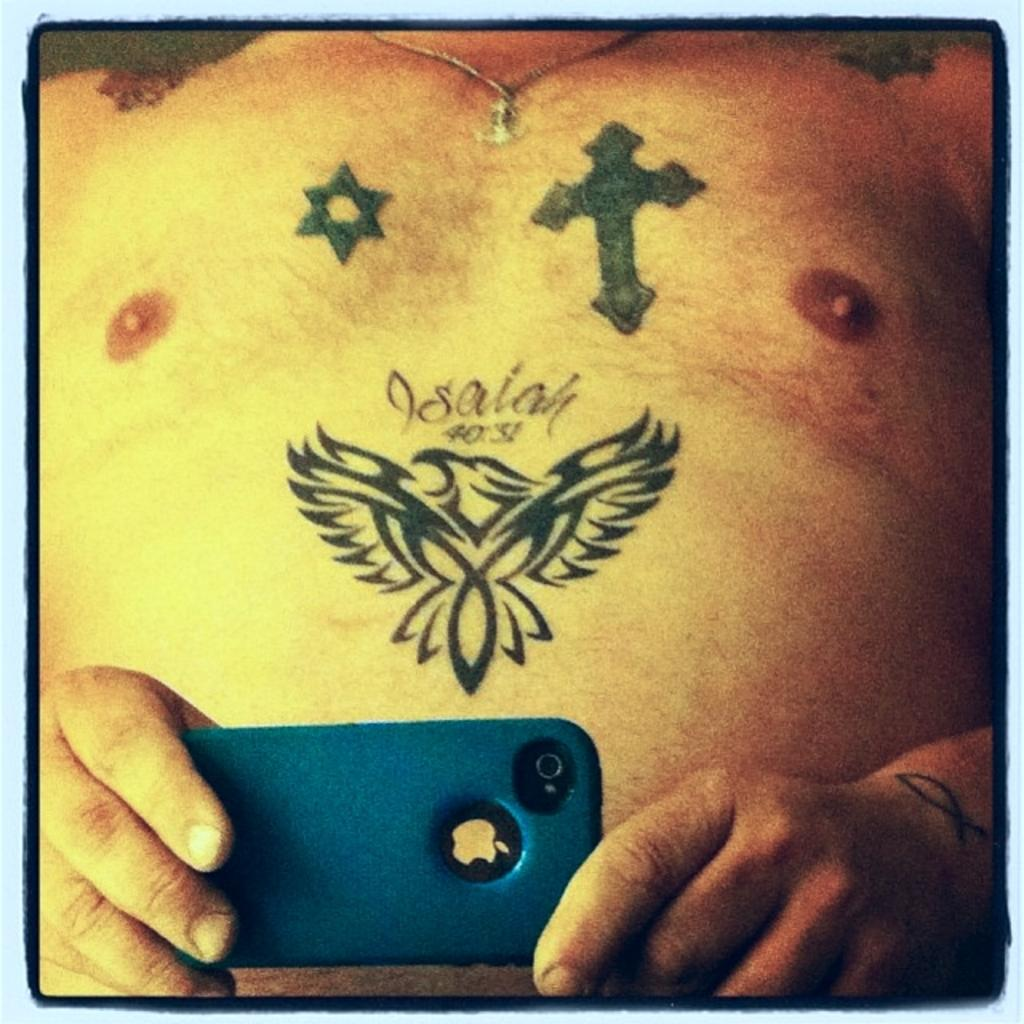What is the main subject of the image? There is a person in the image. What is the person holding in the image? The person is holding a mobile in the image. Can you describe any distinguishing features of the person? The person has tattoos and is wearing a chain. What type of pickle is the person eating in the image? There is no pickle present in the image, so it cannot be determined what type of pickle the person might be eating. 